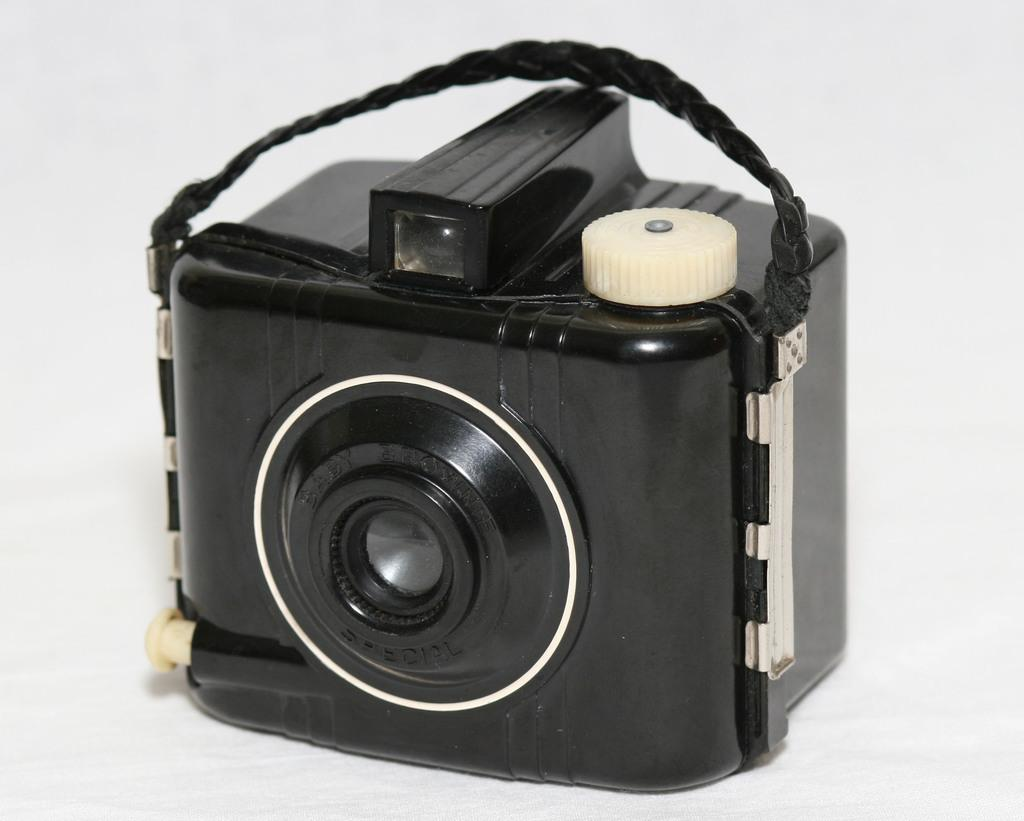What object is placed on the surface in the image? There is a camera on the surface in the image. What might the camera be used for? The camera might be used for capturing images or videos. Can you describe the surface where the camera is placed? The surface is not described in the provided facts, so it cannot be determined from the image. How many parcels are being processed in the image? There are no parcels or any indication of a process in the image; it only features a camera on a surface. 